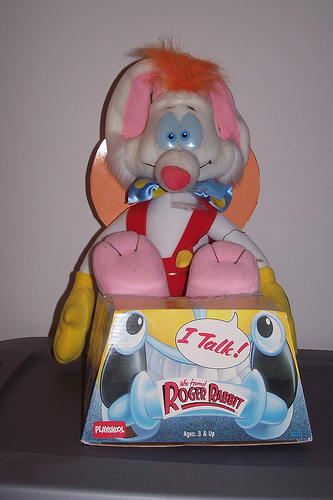<image>
Is the roger on the box? No. The roger is not positioned on the box. They may be near each other, but the roger is not supported by or resting on top of the box. 